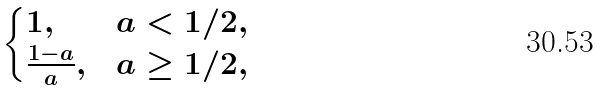<formula> <loc_0><loc_0><loc_500><loc_500>\begin{cases} 1 , & a < 1 / 2 , \\ \frac { 1 - a } { a } , & a \geq 1 / 2 , \end{cases}</formula> 